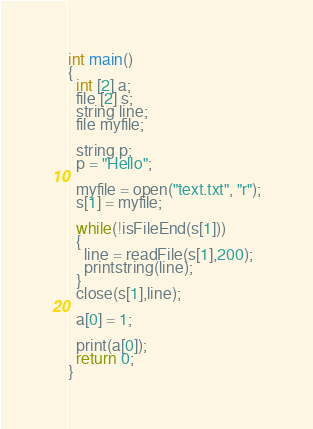<code> <loc_0><loc_0><loc_500><loc_500><_ObjectiveC_>
int main()
{
  int [2] a;
  file [2] s;
  string line;
  file myfile;

  string p;
  p = "Hello";

  myfile = open("text.txt", "r");
  s[1] = myfile;

  while(!isFileEnd(s[1]))
  {
    line = readFile(s[1],200);
    printstring(line);
  }
  close(s[1],line);

  a[0] = 1;

  print(a[0]);
  return 0;
}
</code> 